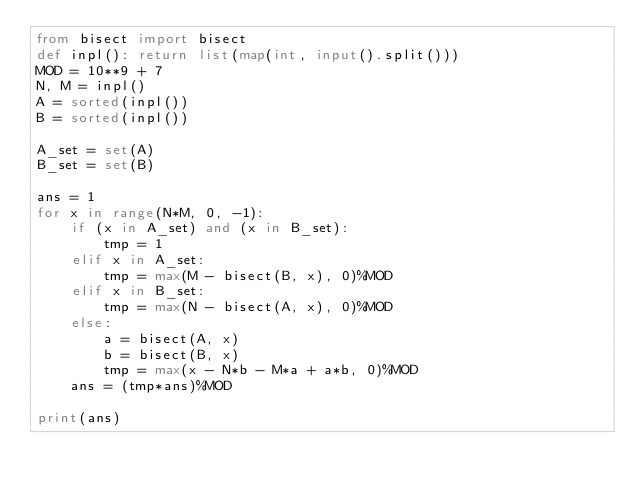<code> <loc_0><loc_0><loc_500><loc_500><_Python_>from bisect import bisect
def inpl(): return list(map(int, input().split()))
MOD = 10**9 + 7
N, M = inpl()
A = sorted(inpl())
B = sorted(inpl())

A_set = set(A)
B_set = set(B)

ans = 1
for x in range(N*M, 0, -1):
    if (x in A_set) and (x in B_set):
        tmp = 1
    elif x in A_set:
        tmp = max(M - bisect(B, x), 0)%MOD
    elif x in B_set:
        tmp = max(N - bisect(A, x), 0)%MOD
    else:
        a = bisect(A, x)
        b = bisect(B, x)
        tmp = max(x - N*b - M*a + a*b, 0)%MOD
    ans = (tmp*ans)%MOD

print(ans)
</code> 